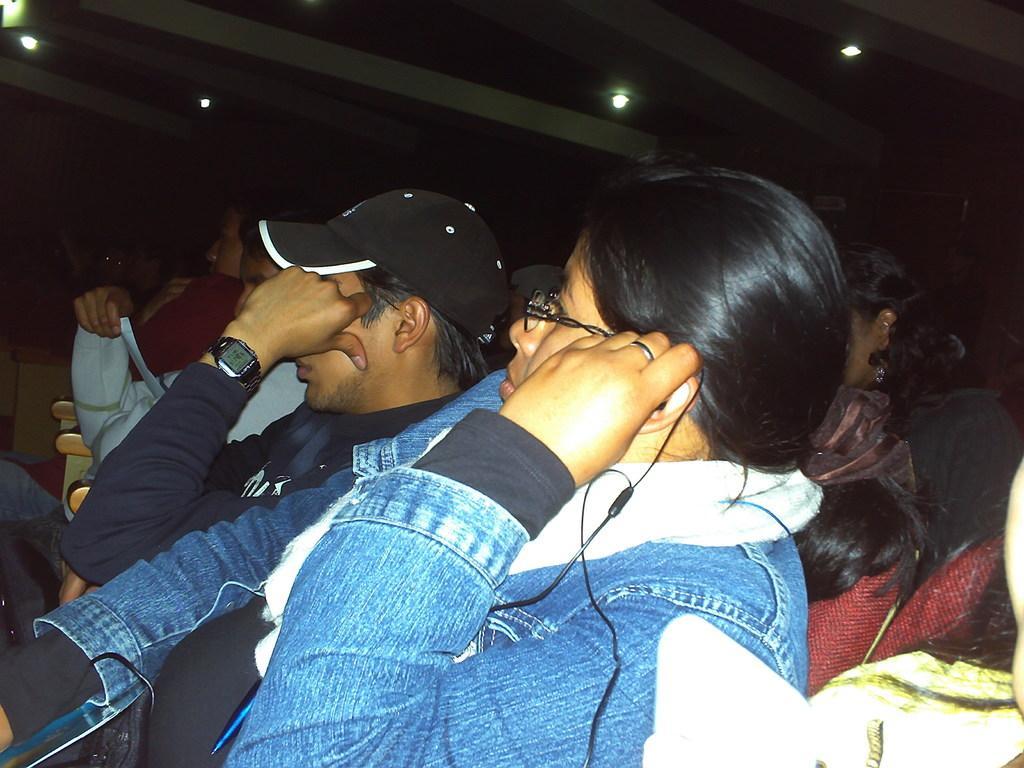Please provide a concise description of this image. In the foreground of the image we can see this person wearing a jean jacket and spectacles is holding earphones and sitting on the chair. Here we can see a few more people sitting on the chairs and the background of the image is dark where we can see the ceiling lights. 